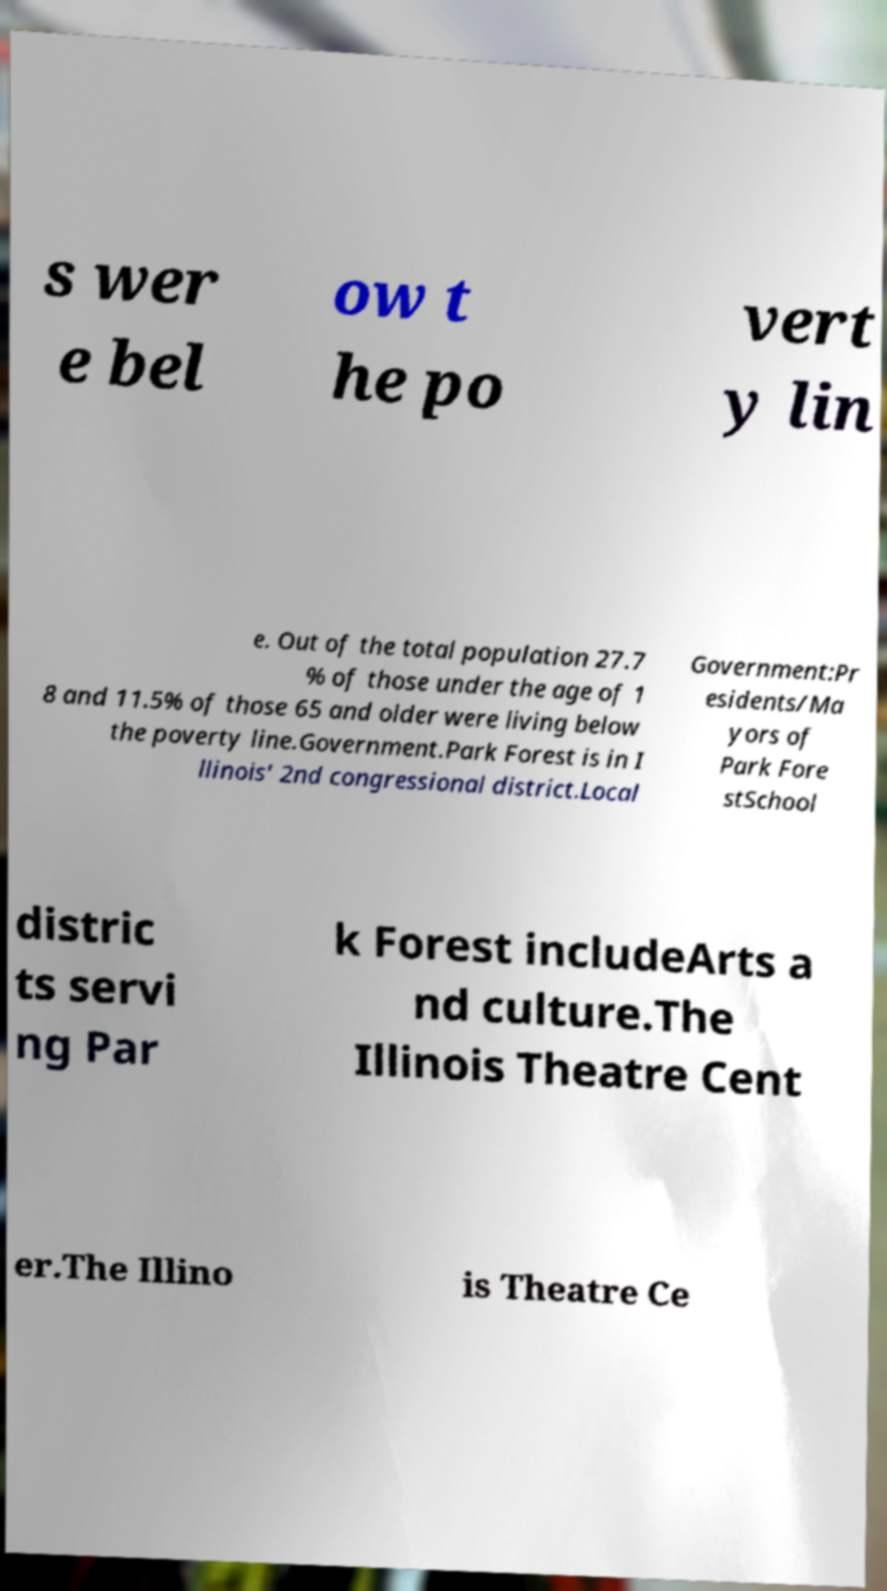For documentation purposes, I need the text within this image transcribed. Could you provide that? s wer e bel ow t he po vert y lin e. Out of the total population 27.7 % of those under the age of 1 8 and 11.5% of those 65 and older were living below the poverty line.Government.Park Forest is in I llinois' 2nd congressional district.Local Government:Pr esidents/Ma yors of Park Fore stSchool distric ts servi ng Par k Forest includeArts a nd culture.The Illinois Theatre Cent er.The Illino is Theatre Ce 